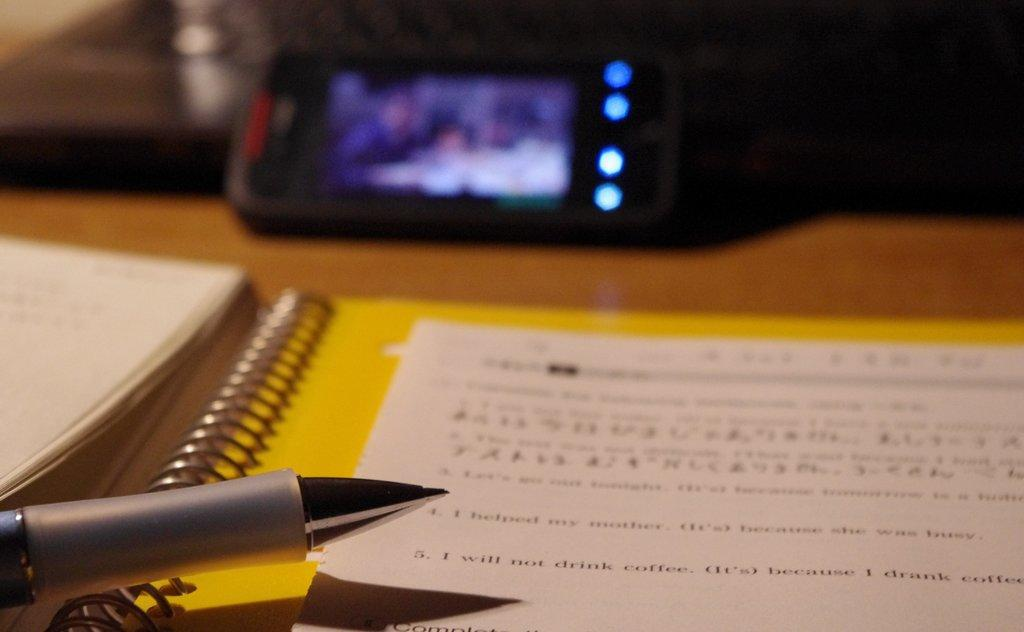What type of furniture is present in the image? There is a table in the image. What is placed on the table? There is a mobile, a file, a book, paper, and a pen on the table. Can you describe the condition of the image at the top? The image is blur at the top. What type of organization is being rewarded for their amusement park in the image? There is no organization, amusement park, or reward present in the image. 